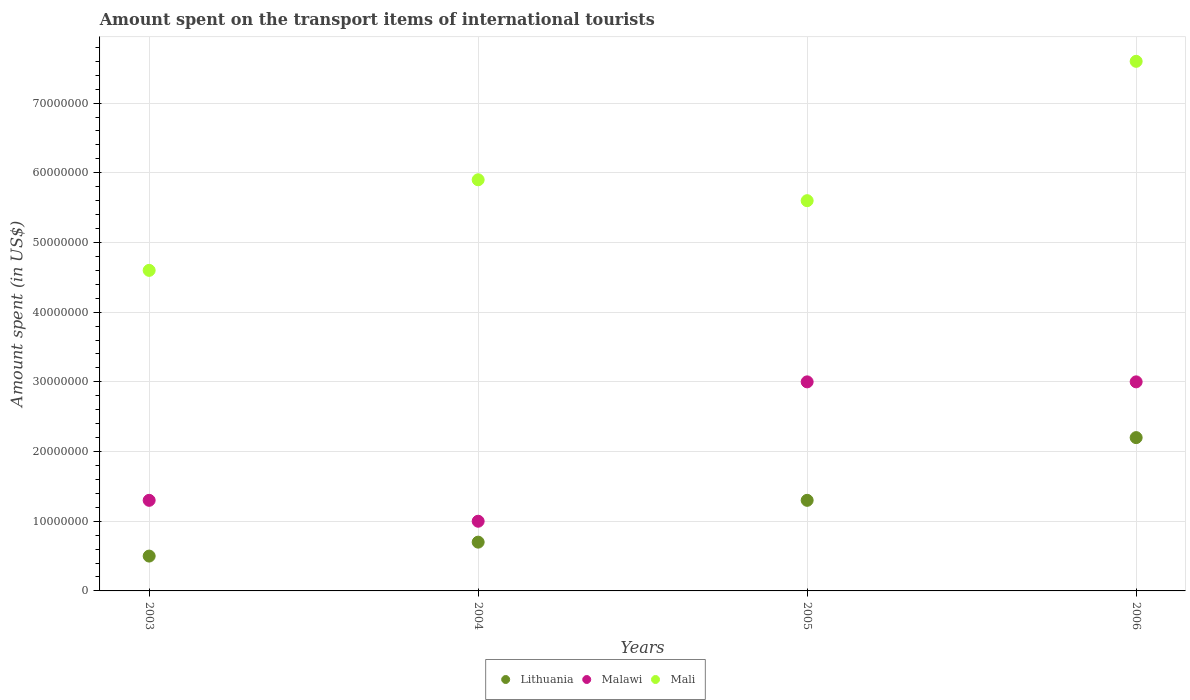How many different coloured dotlines are there?
Ensure brevity in your answer.  3. What is the amount spent on the transport items of international tourists in Lithuania in 2004?
Provide a short and direct response. 7.00e+06. Across all years, what is the maximum amount spent on the transport items of international tourists in Lithuania?
Your answer should be compact. 2.20e+07. Across all years, what is the minimum amount spent on the transport items of international tourists in Malawi?
Make the answer very short. 1.00e+07. In which year was the amount spent on the transport items of international tourists in Mali maximum?
Your answer should be very brief. 2006. What is the total amount spent on the transport items of international tourists in Lithuania in the graph?
Provide a short and direct response. 4.70e+07. What is the difference between the amount spent on the transport items of international tourists in Mali in 2006 and the amount spent on the transport items of international tourists in Malawi in 2003?
Give a very brief answer. 6.30e+07. What is the average amount spent on the transport items of international tourists in Lithuania per year?
Ensure brevity in your answer.  1.18e+07. In the year 2005, what is the difference between the amount spent on the transport items of international tourists in Mali and amount spent on the transport items of international tourists in Malawi?
Your response must be concise. 2.60e+07. In how many years, is the amount spent on the transport items of international tourists in Malawi greater than 76000000 US$?
Make the answer very short. 0. What is the ratio of the amount spent on the transport items of international tourists in Mali in 2004 to that in 2005?
Keep it short and to the point. 1.05. Is the amount spent on the transport items of international tourists in Lithuania in 2003 less than that in 2006?
Give a very brief answer. Yes. Is the difference between the amount spent on the transport items of international tourists in Mali in 2004 and 2006 greater than the difference between the amount spent on the transport items of international tourists in Malawi in 2004 and 2006?
Your response must be concise. Yes. What is the difference between the highest and the second highest amount spent on the transport items of international tourists in Malawi?
Your answer should be very brief. 0. What is the difference between the highest and the lowest amount spent on the transport items of international tourists in Mali?
Provide a succinct answer. 3.00e+07. Is the sum of the amount spent on the transport items of international tourists in Malawi in 2004 and 2005 greater than the maximum amount spent on the transport items of international tourists in Lithuania across all years?
Ensure brevity in your answer.  Yes. Does the amount spent on the transport items of international tourists in Lithuania monotonically increase over the years?
Give a very brief answer. Yes. Is the amount spent on the transport items of international tourists in Mali strictly greater than the amount spent on the transport items of international tourists in Lithuania over the years?
Ensure brevity in your answer.  Yes. How many years are there in the graph?
Your answer should be compact. 4. What is the difference between two consecutive major ticks on the Y-axis?
Keep it short and to the point. 1.00e+07. Does the graph contain grids?
Provide a succinct answer. Yes. Where does the legend appear in the graph?
Give a very brief answer. Bottom center. What is the title of the graph?
Offer a very short reply. Amount spent on the transport items of international tourists. Does "Belarus" appear as one of the legend labels in the graph?
Your answer should be very brief. No. What is the label or title of the Y-axis?
Offer a very short reply. Amount spent (in US$). What is the Amount spent (in US$) in Malawi in 2003?
Give a very brief answer. 1.30e+07. What is the Amount spent (in US$) in Mali in 2003?
Give a very brief answer. 4.60e+07. What is the Amount spent (in US$) of Mali in 2004?
Give a very brief answer. 5.90e+07. What is the Amount spent (in US$) of Lithuania in 2005?
Offer a very short reply. 1.30e+07. What is the Amount spent (in US$) in Malawi in 2005?
Your response must be concise. 3.00e+07. What is the Amount spent (in US$) of Mali in 2005?
Ensure brevity in your answer.  5.60e+07. What is the Amount spent (in US$) of Lithuania in 2006?
Offer a terse response. 2.20e+07. What is the Amount spent (in US$) in Malawi in 2006?
Keep it short and to the point. 3.00e+07. What is the Amount spent (in US$) of Mali in 2006?
Keep it short and to the point. 7.60e+07. Across all years, what is the maximum Amount spent (in US$) in Lithuania?
Offer a terse response. 2.20e+07. Across all years, what is the maximum Amount spent (in US$) in Malawi?
Your answer should be very brief. 3.00e+07. Across all years, what is the maximum Amount spent (in US$) of Mali?
Offer a terse response. 7.60e+07. Across all years, what is the minimum Amount spent (in US$) in Lithuania?
Offer a terse response. 5.00e+06. Across all years, what is the minimum Amount spent (in US$) of Malawi?
Keep it short and to the point. 1.00e+07. Across all years, what is the minimum Amount spent (in US$) in Mali?
Offer a terse response. 4.60e+07. What is the total Amount spent (in US$) of Lithuania in the graph?
Provide a short and direct response. 4.70e+07. What is the total Amount spent (in US$) of Malawi in the graph?
Give a very brief answer. 8.30e+07. What is the total Amount spent (in US$) in Mali in the graph?
Provide a succinct answer. 2.37e+08. What is the difference between the Amount spent (in US$) in Lithuania in 2003 and that in 2004?
Provide a succinct answer. -2.00e+06. What is the difference between the Amount spent (in US$) in Malawi in 2003 and that in 2004?
Offer a very short reply. 3.00e+06. What is the difference between the Amount spent (in US$) of Mali in 2003 and that in 2004?
Keep it short and to the point. -1.30e+07. What is the difference between the Amount spent (in US$) in Lithuania in 2003 and that in 2005?
Your response must be concise. -8.00e+06. What is the difference between the Amount spent (in US$) of Malawi in 2003 and that in 2005?
Your response must be concise. -1.70e+07. What is the difference between the Amount spent (in US$) of Mali in 2003 and that in 2005?
Your answer should be very brief. -1.00e+07. What is the difference between the Amount spent (in US$) in Lithuania in 2003 and that in 2006?
Your answer should be compact. -1.70e+07. What is the difference between the Amount spent (in US$) of Malawi in 2003 and that in 2006?
Offer a very short reply. -1.70e+07. What is the difference between the Amount spent (in US$) in Mali in 2003 and that in 2006?
Keep it short and to the point. -3.00e+07. What is the difference between the Amount spent (in US$) in Lithuania in 2004 and that in 2005?
Your answer should be compact. -6.00e+06. What is the difference between the Amount spent (in US$) of Malawi in 2004 and that in 2005?
Provide a succinct answer. -2.00e+07. What is the difference between the Amount spent (in US$) of Lithuania in 2004 and that in 2006?
Your response must be concise. -1.50e+07. What is the difference between the Amount spent (in US$) in Malawi in 2004 and that in 2006?
Ensure brevity in your answer.  -2.00e+07. What is the difference between the Amount spent (in US$) in Mali in 2004 and that in 2006?
Your answer should be very brief. -1.70e+07. What is the difference between the Amount spent (in US$) in Lithuania in 2005 and that in 2006?
Your answer should be very brief. -9.00e+06. What is the difference between the Amount spent (in US$) in Malawi in 2005 and that in 2006?
Make the answer very short. 0. What is the difference between the Amount spent (in US$) of Mali in 2005 and that in 2006?
Make the answer very short. -2.00e+07. What is the difference between the Amount spent (in US$) in Lithuania in 2003 and the Amount spent (in US$) in Malawi in 2004?
Give a very brief answer. -5.00e+06. What is the difference between the Amount spent (in US$) of Lithuania in 2003 and the Amount spent (in US$) of Mali in 2004?
Give a very brief answer. -5.40e+07. What is the difference between the Amount spent (in US$) in Malawi in 2003 and the Amount spent (in US$) in Mali in 2004?
Provide a short and direct response. -4.60e+07. What is the difference between the Amount spent (in US$) in Lithuania in 2003 and the Amount spent (in US$) in Malawi in 2005?
Your answer should be very brief. -2.50e+07. What is the difference between the Amount spent (in US$) in Lithuania in 2003 and the Amount spent (in US$) in Mali in 2005?
Offer a terse response. -5.10e+07. What is the difference between the Amount spent (in US$) of Malawi in 2003 and the Amount spent (in US$) of Mali in 2005?
Give a very brief answer. -4.30e+07. What is the difference between the Amount spent (in US$) in Lithuania in 2003 and the Amount spent (in US$) in Malawi in 2006?
Keep it short and to the point. -2.50e+07. What is the difference between the Amount spent (in US$) in Lithuania in 2003 and the Amount spent (in US$) in Mali in 2006?
Your answer should be compact. -7.10e+07. What is the difference between the Amount spent (in US$) in Malawi in 2003 and the Amount spent (in US$) in Mali in 2006?
Provide a succinct answer. -6.30e+07. What is the difference between the Amount spent (in US$) in Lithuania in 2004 and the Amount spent (in US$) in Malawi in 2005?
Your response must be concise. -2.30e+07. What is the difference between the Amount spent (in US$) of Lithuania in 2004 and the Amount spent (in US$) of Mali in 2005?
Offer a very short reply. -4.90e+07. What is the difference between the Amount spent (in US$) of Malawi in 2004 and the Amount spent (in US$) of Mali in 2005?
Provide a succinct answer. -4.60e+07. What is the difference between the Amount spent (in US$) in Lithuania in 2004 and the Amount spent (in US$) in Malawi in 2006?
Provide a short and direct response. -2.30e+07. What is the difference between the Amount spent (in US$) of Lithuania in 2004 and the Amount spent (in US$) of Mali in 2006?
Make the answer very short. -6.90e+07. What is the difference between the Amount spent (in US$) in Malawi in 2004 and the Amount spent (in US$) in Mali in 2006?
Keep it short and to the point. -6.60e+07. What is the difference between the Amount spent (in US$) of Lithuania in 2005 and the Amount spent (in US$) of Malawi in 2006?
Provide a succinct answer. -1.70e+07. What is the difference between the Amount spent (in US$) in Lithuania in 2005 and the Amount spent (in US$) in Mali in 2006?
Offer a very short reply. -6.30e+07. What is the difference between the Amount spent (in US$) in Malawi in 2005 and the Amount spent (in US$) in Mali in 2006?
Keep it short and to the point. -4.60e+07. What is the average Amount spent (in US$) of Lithuania per year?
Offer a very short reply. 1.18e+07. What is the average Amount spent (in US$) of Malawi per year?
Offer a terse response. 2.08e+07. What is the average Amount spent (in US$) of Mali per year?
Ensure brevity in your answer.  5.92e+07. In the year 2003, what is the difference between the Amount spent (in US$) in Lithuania and Amount spent (in US$) in Malawi?
Make the answer very short. -8.00e+06. In the year 2003, what is the difference between the Amount spent (in US$) in Lithuania and Amount spent (in US$) in Mali?
Your response must be concise. -4.10e+07. In the year 2003, what is the difference between the Amount spent (in US$) of Malawi and Amount spent (in US$) of Mali?
Make the answer very short. -3.30e+07. In the year 2004, what is the difference between the Amount spent (in US$) of Lithuania and Amount spent (in US$) of Mali?
Keep it short and to the point. -5.20e+07. In the year 2004, what is the difference between the Amount spent (in US$) in Malawi and Amount spent (in US$) in Mali?
Give a very brief answer. -4.90e+07. In the year 2005, what is the difference between the Amount spent (in US$) in Lithuania and Amount spent (in US$) in Malawi?
Make the answer very short. -1.70e+07. In the year 2005, what is the difference between the Amount spent (in US$) of Lithuania and Amount spent (in US$) of Mali?
Your response must be concise. -4.30e+07. In the year 2005, what is the difference between the Amount spent (in US$) of Malawi and Amount spent (in US$) of Mali?
Your answer should be very brief. -2.60e+07. In the year 2006, what is the difference between the Amount spent (in US$) in Lithuania and Amount spent (in US$) in Malawi?
Offer a very short reply. -8.00e+06. In the year 2006, what is the difference between the Amount spent (in US$) of Lithuania and Amount spent (in US$) of Mali?
Make the answer very short. -5.40e+07. In the year 2006, what is the difference between the Amount spent (in US$) of Malawi and Amount spent (in US$) of Mali?
Your response must be concise. -4.60e+07. What is the ratio of the Amount spent (in US$) in Malawi in 2003 to that in 2004?
Make the answer very short. 1.3. What is the ratio of the Amount spent (in US$) in Mali in 2003 to that in 2004?
Give a very brief answer. 0.78. What is the ratio of the Amount spent (in US$) of Lithuania in 2003 to that in 2005?
Keep it short and to the point. 0.38. What is the ratio of the Amount spent (in US$) in Malawi in 2003 to that in 2005?
Provide a succinct answer. 0.43. What is the ratio of the Amount spent (in US$) of Mali in 2003 to that in 2005?
Your answer should be very brief. 0.82. What is the ratio of the Amount spent (in US$) of Lithuania in 2003 to that in 2006?
Make the answer very short. 0.23. What is the ratio of the Amount spent (in US$) in Malawi in 2003 to that in 2006?
Offer a very short reply. 0.43. What is the ratio of the Amount spent (in US$) of Mali in 2003 to that in 2006?
Your answer should be very brief. 0.61. What is the ratio of the Amount spent (in US$) of Lithuania in 2004 to that in 2005?
Offer a very short reply. 0.54. What is the ratio of the Amount spent (in US$) in Malawi in 2004 to that in 2005?
Offer a very short reply. 0.33. What is the ratio of the Amount spent (in US$) in Mali in 2004 to that in 2005?
Offer a very short reply. 1.05. What is the ratio of the Amount spent (in US$) of Lithuania in 2004 to that in 2006?
Provide a short and direct response. 0.32. What is the ratio of the Amount spent (in US$) in Malawi in 2004 to that in 2006?
Make the answer very short. 0.33. What is the ratio of the Amount spent (in US$) of Mali in 2004 to that in 2006?
Keep it short and to the point. 0.78. What is the ratio of the Amount spent (in US$) in Lithuania in 2005 to that in 2006?
Make the answer very short. 0.59. What is the ratio of the Amount spent (in US$) in Mali in 2005 to that in 2006?
Give a very brief answer. 0.74. What is the difference between the highest and the second highest Amount spent (in US$) in Lithuania?
Give a very brief answer. 9.00e+06. What is the difference between the highest and the second highest Amount spent (in US$) of Malawi?
Provide a short and direct response. 0. What is the difference between the highest and the second highest Amount spent (in US$) of Mali?
Keep it short and to the point. 1.70e+07. What is the difference between the highest and the lowest Amount spent (in US$) of Lithuania?
Offer a very short reply. 1.70e+07. What is the difference between the highest and the lowest Amount spent (in US$) of Malawi?
Offer a very short reply. 2.00e+07. What is the difference between the highest and the lowest Amount spent (in US$) in Mali?
Offer a terse response. 3.00e+07. 